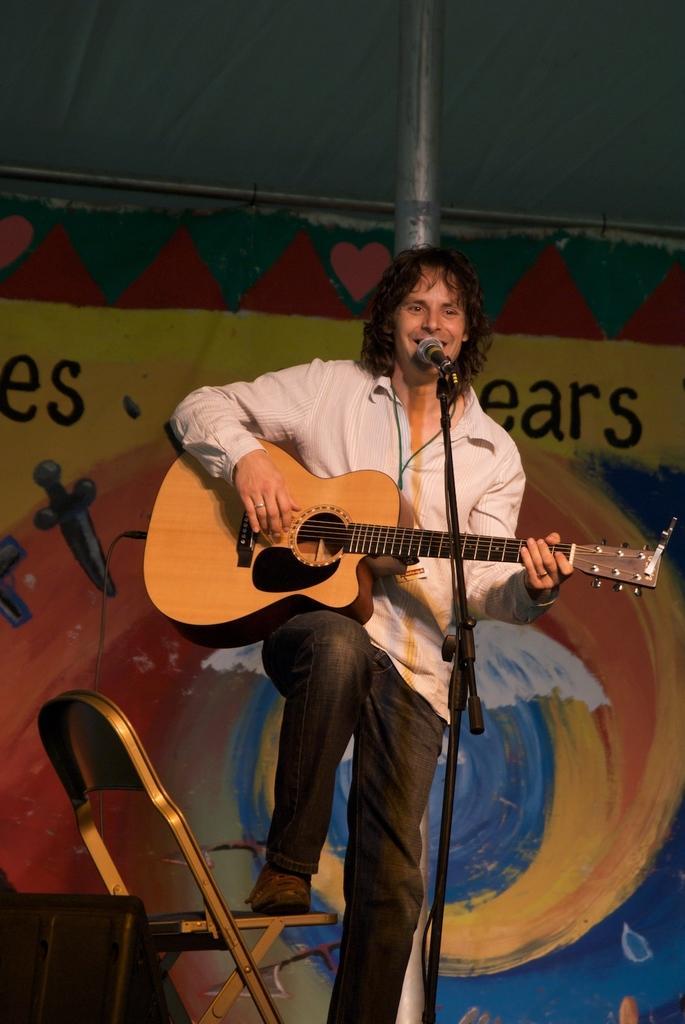Can you describe this image briefly? In this picture there is a boy who is standing in front of the mice by holding a guitar, the boy is placed his leg on the chair which is left side of the image, there is a big poster of different colors which is there on the wall behind the boy and there is a speaker on the stage which is placed at the left side of the image. 